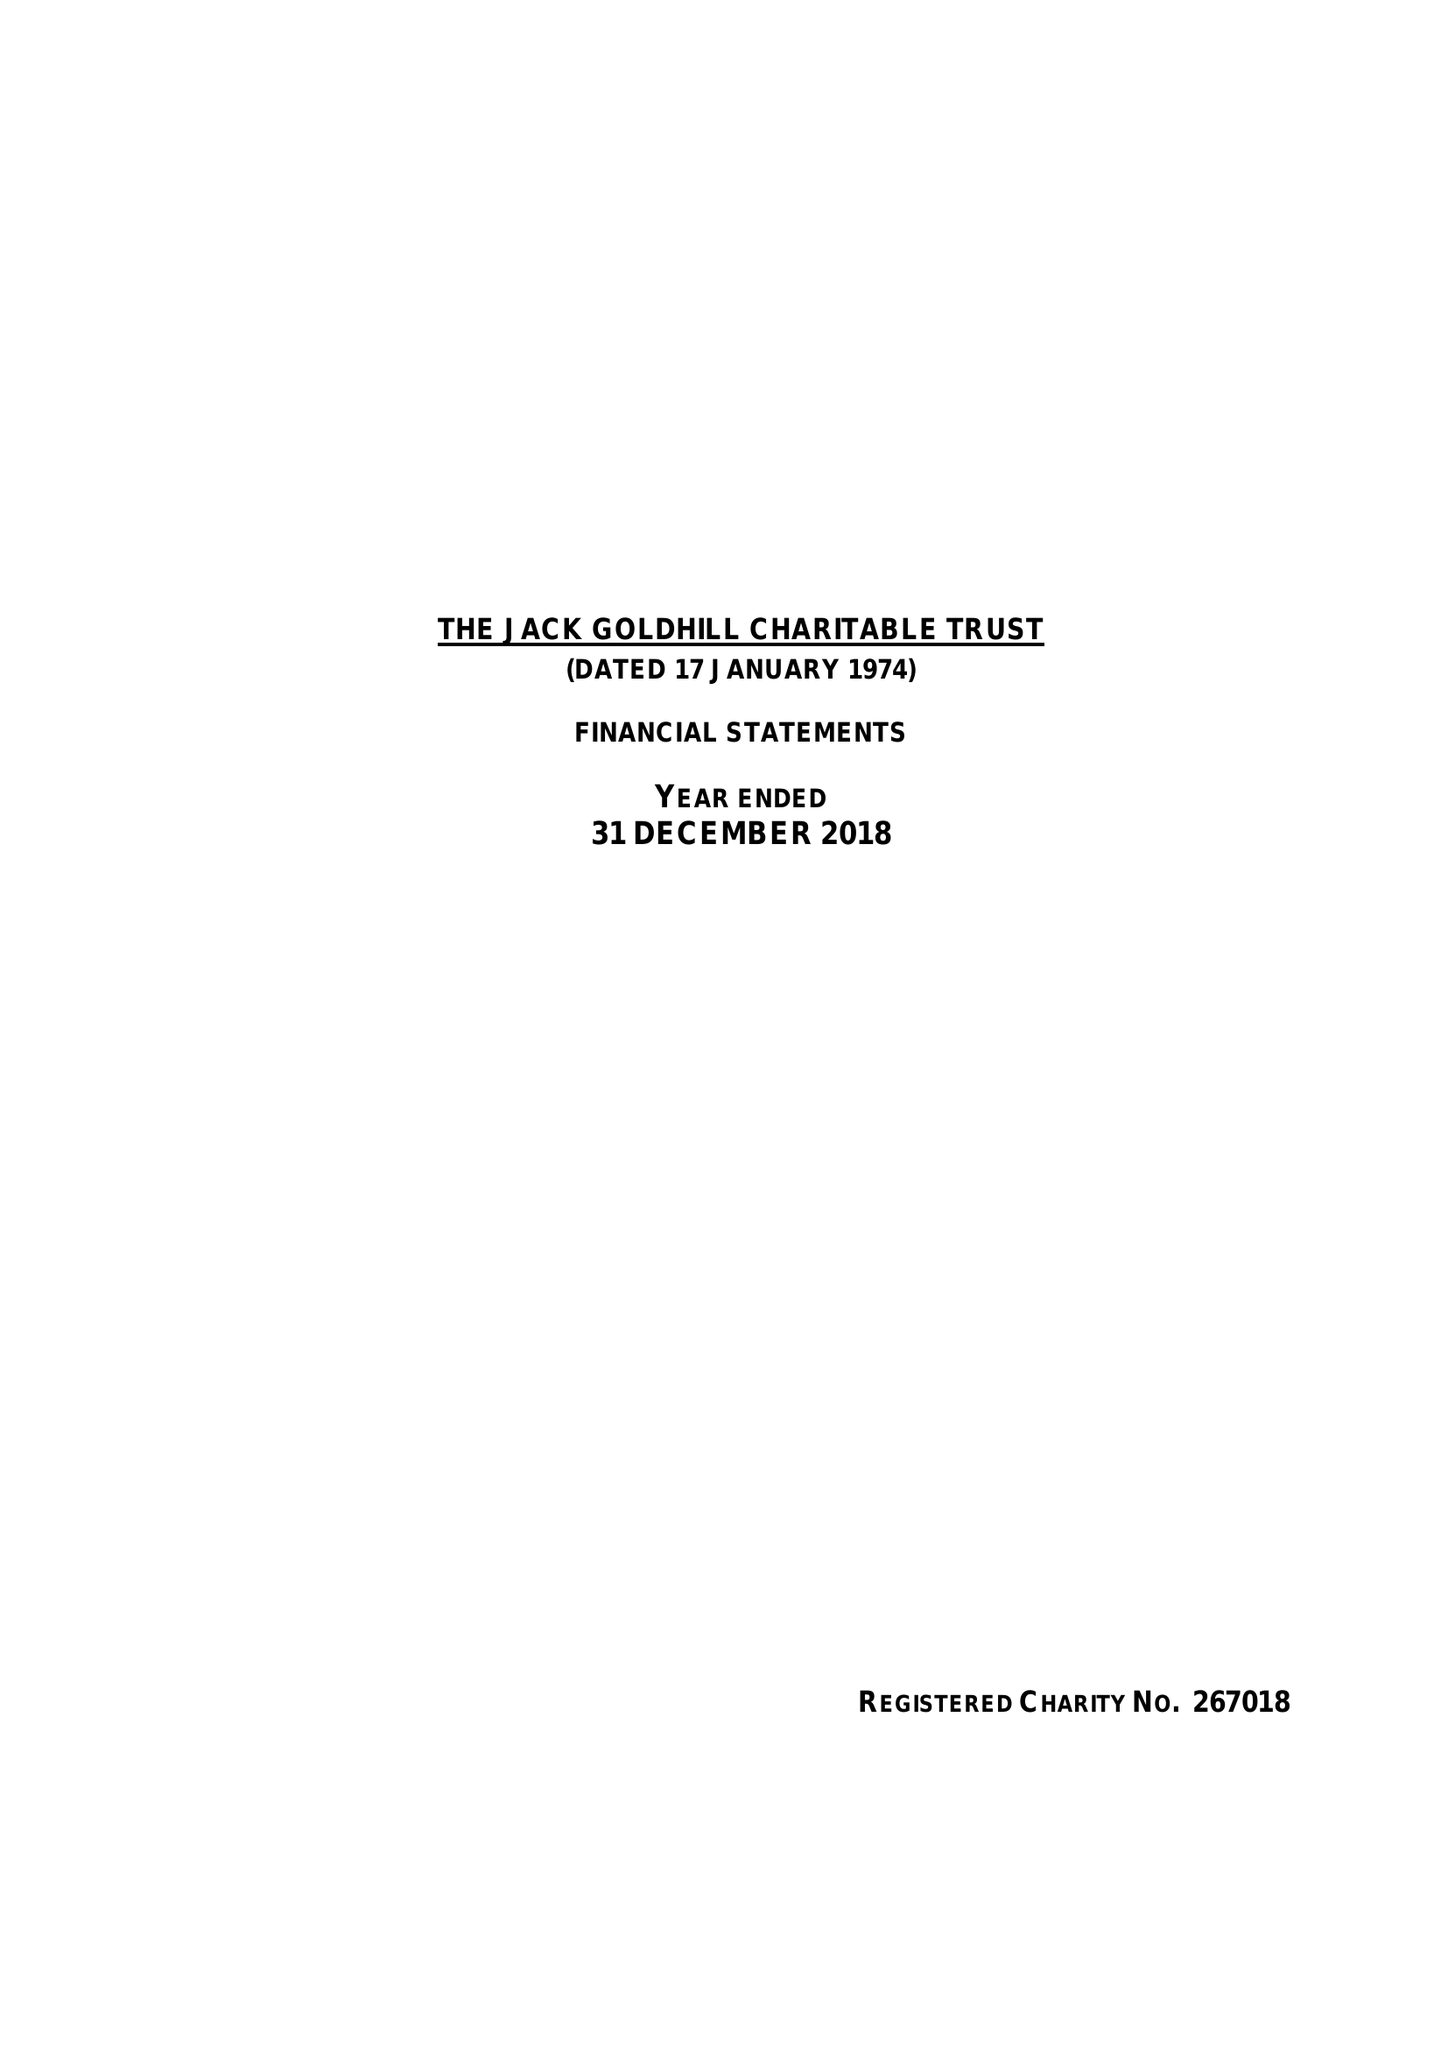What is the value for the address__post_town?
Answer the question using a single word or phrase. LONDON 